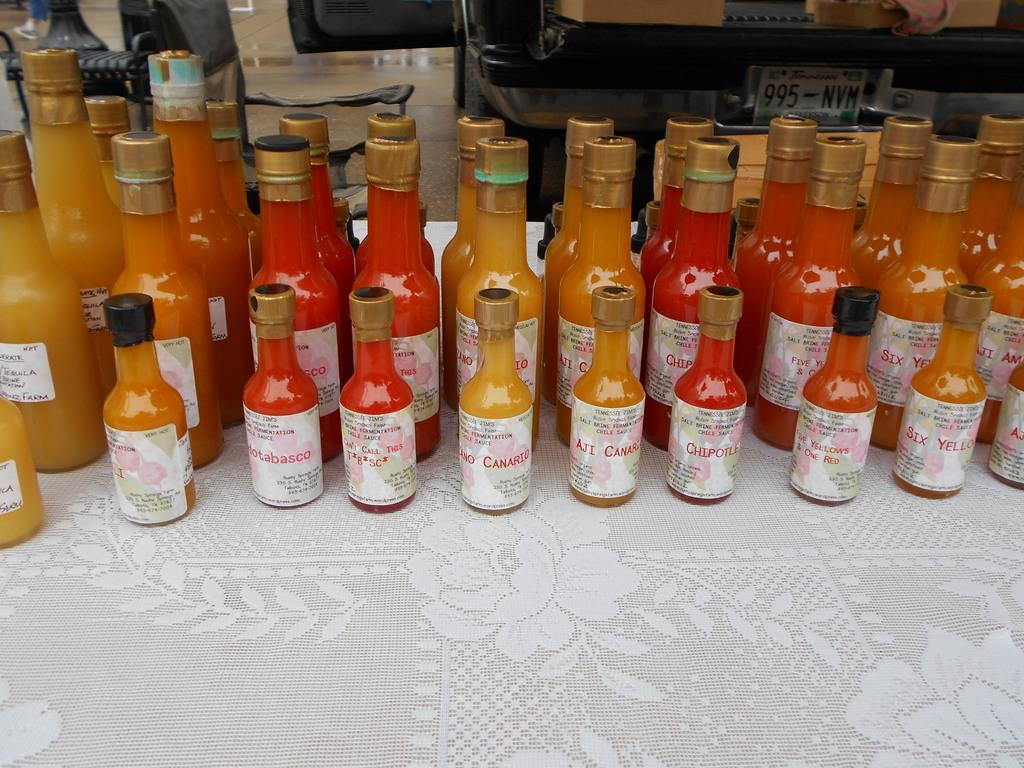What objects are on the table in the image? There are bottles on the table in the image. Can you describe anything in the background of the image? There is a chair visible in the background of the image. What type of vessel is being used for lunch in the image? There is no vessel or lunch present in the image; it only features bottles on the table and a chair in the background. 